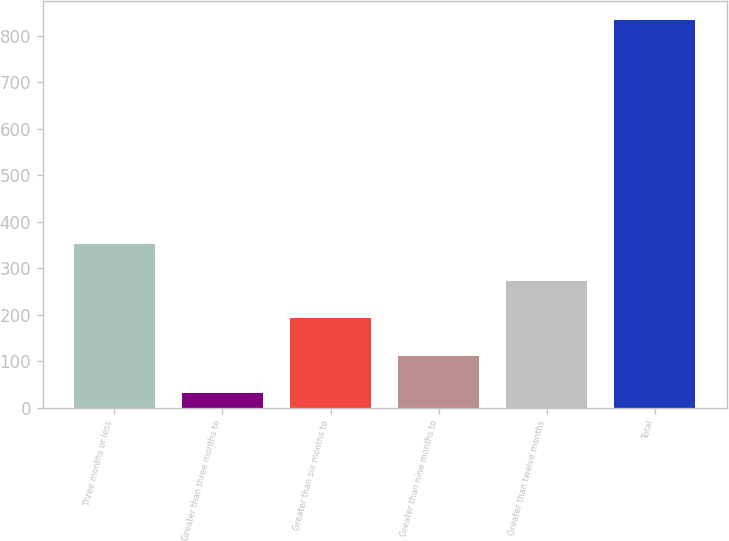Convert chart to OTSL. <chart><loc_0><loc_0><loc_500><loc_500><bar_chart><fcel>Three months or less<fcel>Greater than three months to<fcel>Greater than six months to<fcel>Greater than nine months to<fcel>Greater than twelve months<fcel>Total<nl><fcel>352.8<fcel>32<fcel>192.4<fcel>112.2<fcel>272.6<fcel>834<nl></chart> 